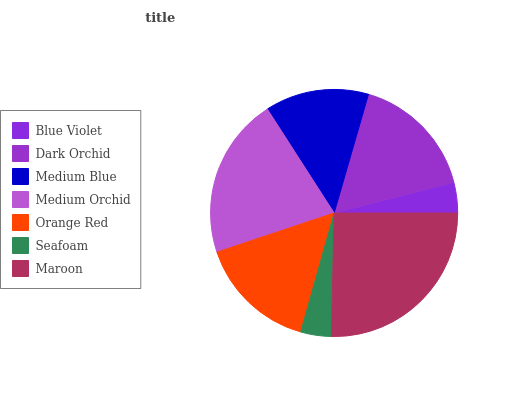Is Blue Violet the minimum?
Answer yes or no. Yes. Is Maroon the maximum?
Answer yes or no. Yes. Is Dark Orchid the minimum?
Answer yes or no. No. Is Dark Orchid the maximum?
Answer yes or no. No. Is Dark Orchid greater than Blue Violet?
Answer yes or no. Yes. Is Blue Violet less than Dark Orchid?
Answer yes or no. Yes. Is Blue Violet greater than Dark Orchid?
Answer yes or no. No. Is Dark Orchid less than Blue Violet?
Answer yes or no. No. Is Orange Red the high median?
Answer yes or no. Yes. Is Orange Red the low median?
Answer yes or no. Yes. Is Dark Orchid the high median?
Answer yes or no. No. Is Dark Orchid the low median?
Answer yes or no. No. 